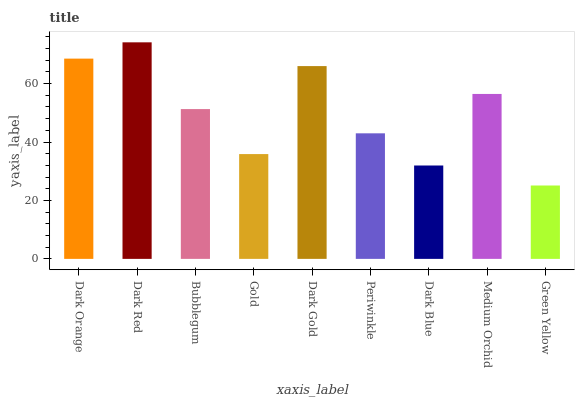Is Green Yellow the minimum?
Answer yes or no. Yes. Is Dark Red the maximum?
Answer yes or no. Yes. Is Bubblegum the minimum?
Answer yes or no. No. Is Bubblegum the maximum?
Answer yes or no. No. Is Dark Red greater than Bubblegum?
Answer yes or no. Yes. Is Bubblegum less than Dark Red?
Answer yes or no. Yes. Is Bubblegum greater than Dark Red?
Answer yes or no. No. Is Dark Red less than Bubblegum?
Answer yes or no. No. Is Bubblegum the high median?
Answer yes or no. Yes. Is Bubblegum the low median?
Answer yes or no. Yes. Is Periwinkle the high median?
Answer yes or no. No. Is Green Yellow the low median?
Answer yes or no. No. 